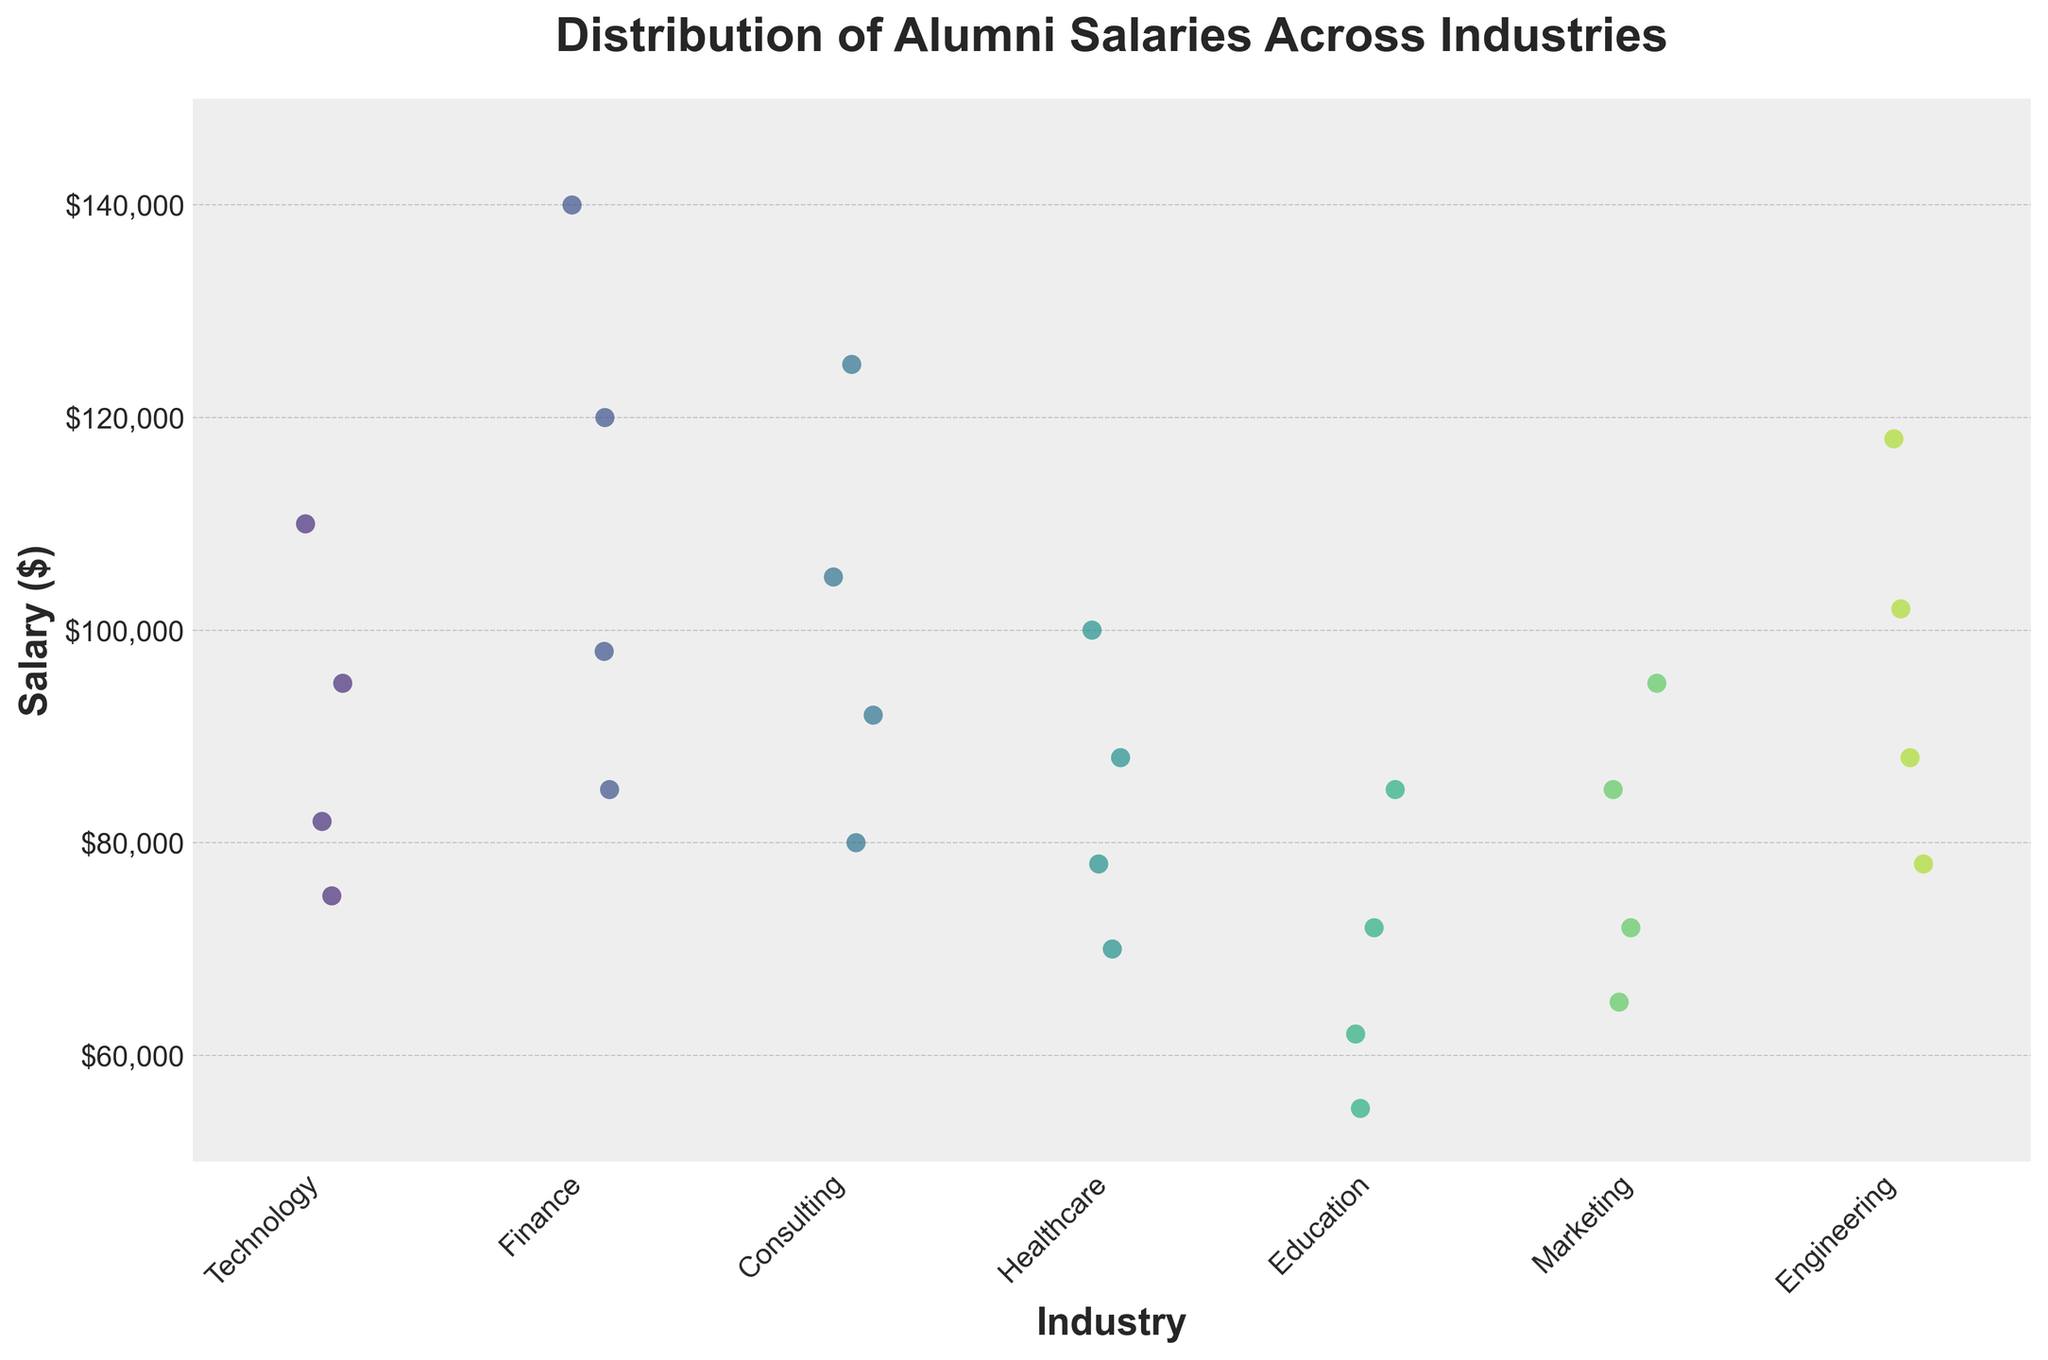What is the title of the figure? The title is displayed at the top of the figure, which provides a summary of what the graph is about.
Answer: Distribution of Alumni Salaries Across Industries How many different industries are represented in the figure? Each unique industry name along the x-axis represents a different industry. Counting them will give the answer.
Answer: 7 What is the salary range shown on the y-axis of the figure? The y-axis labels provide the range, with the minimum and maximum values shown at the axis limits.
Answer: $50,000 to $150,000 Which industry shows the highest individual salary, and what is that salary? Observing the highest data point across all industries on the y-axis, the highest value can be identified.
Answer: Finance, $140,000 Which industry has the most data points (salaries) plotted on the graph? By visually counting the number of points for each industry along the x-axis, the industry with the most points can be identified.
Answer: Technology What is the approximate average salary in the Education industry based on the figure? Estimate the center of the salary distribution for the Education industry by visually averaging the salary data points presented.
Answer: Roughly $68,000 Which industry appears to have the highest average salaries, and why? By comparing the density and general height of the data points for each industry, the one with points clustered at higher salary values indicates a higher average.
Answer: Finance Compare the salary range in the Technology and Education industries. Which one has a wider range? Identify the minimum and maximum salaries for each industry and calculate the range by subtracting the minimum from the maximum for each.
Answer: Technology Is there an industry where the salaries do not exceed $100,000? Name it if there is. Check for the highest salary data points in each industry to identify which industry's highest salary is below $100,000.
Answer: Education How does the distribution of salaries in Healthcare compare to that in Marketing? Observe and compare both industries’ salary points spread and clustering to see if one has a more even distribution or higher concentration.
Answer: Healthcare shows a more even spread between $70,000 and $100,000, whereas Marketing is more concentrated around $65,000 to $95,000 